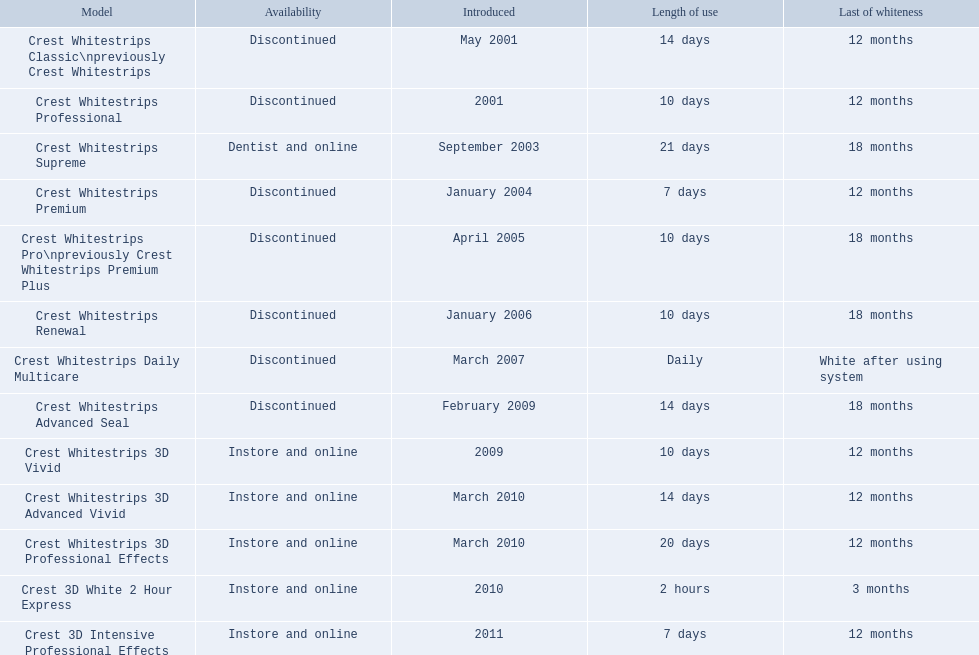What models remain in stock? Crest Whitestrips Supreme, Crest Whitestrips 3D Vivid, Crest Whitestrips 3D Advanced Vivid, Crest Whitestrips 3D Professional Effects, Crest 3D White 2 Hour Express, Crest 3D Intensive Professional Effects. From these, which ones were launched before 2011? Crest Whitestrips Supreme, Crest Whitestrips 3D Vivid, Crest Whitestrips 3D Advanced Vivid, Crest Whitestrips 3D Professional Effects, Crest 3D White 2 Hour Express. Out of these models, which ones required a minimum usage of 14 days? Crest Whitestrips Supreme, Crest Whitestrips 3D Advanced Vivid, Crest Whitestrips 3D Professional Effects. And from that selection, which ones endured for more than 12 months? Crest Whitestrips Supreme. 